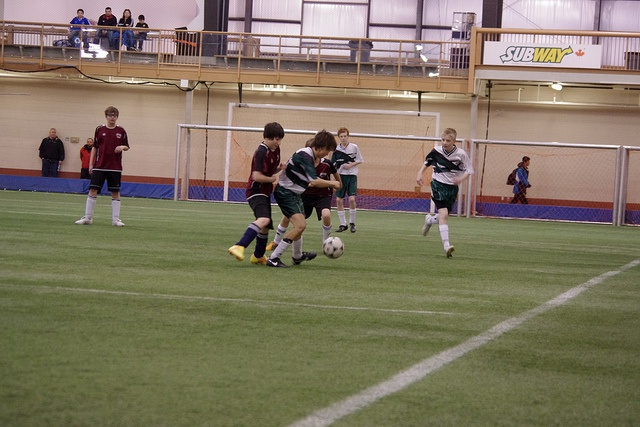Describe the objects in this image and their specific colors. I can see people in gray, black, and darkgray tones, people in gray, black, maroon, and darkgray tones, people in gray, black, and maroon tones, people in gray, black, and darkgray tones, and people in gray, black, and darkgray tones in this image. 